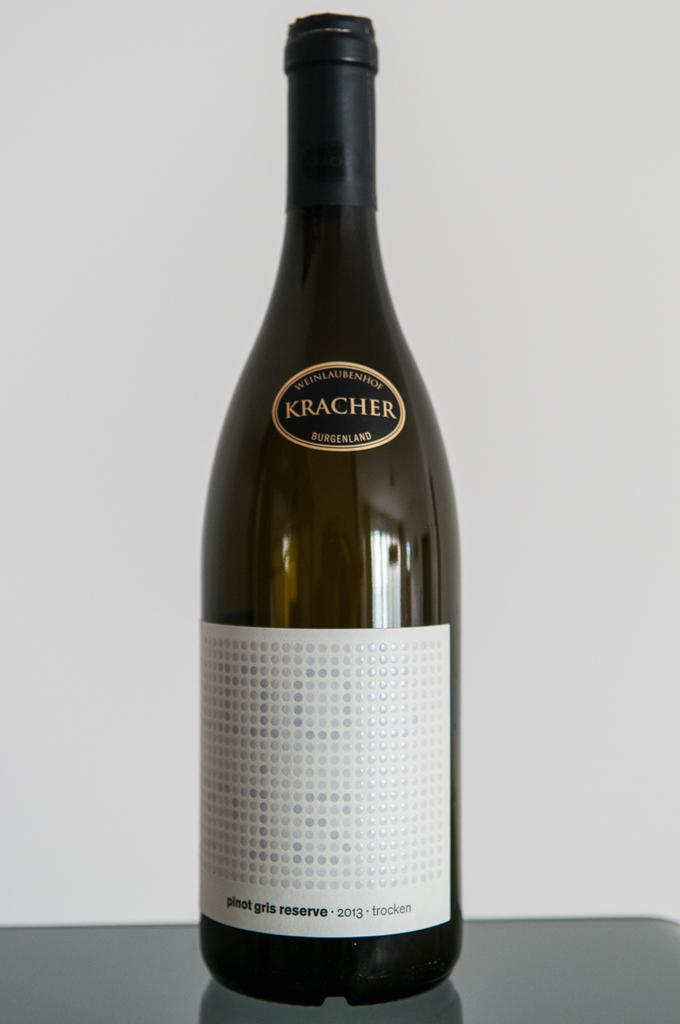<image>
Present a compact description of the photo's key features. A bottle of Kracher Wine sits against a white background on a table 